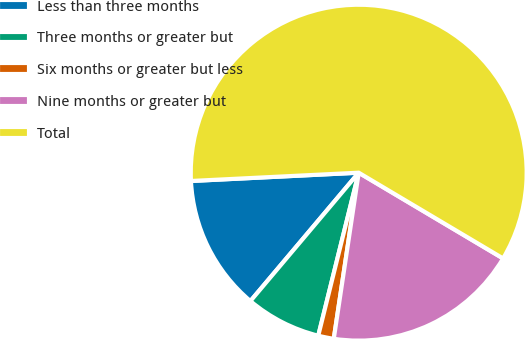Convert chart to OTSL. <chart><loc_0><loc_0><loc_500><loc_500><pie_chart><fcel>Less than three months<fcel>Three months or greater but<fcel>Six months or greater but less<fcel>Nine months or greater but<fcel>Total<nl><fcel>13.06%<fcel>7.28%<fcel>1.5%<fcel>18.84%<fcel>59.31%<nl></chart> 